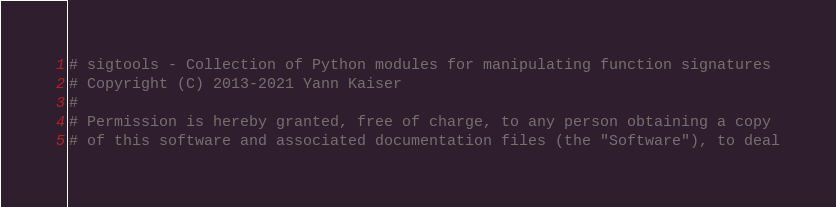Convert code to text. <code><loc_0><loc_0><loc_500><loc_500><_Python_># sigtools - Collection of Python modules for manipulating function signatures
# Copyright (C) 2013-2021 Yann Kaiser
#
# Permission is hereby granted, free of charge, to any person obtaining a copy
# of this software and associated documentation files (the "Software"), to deal</code> 